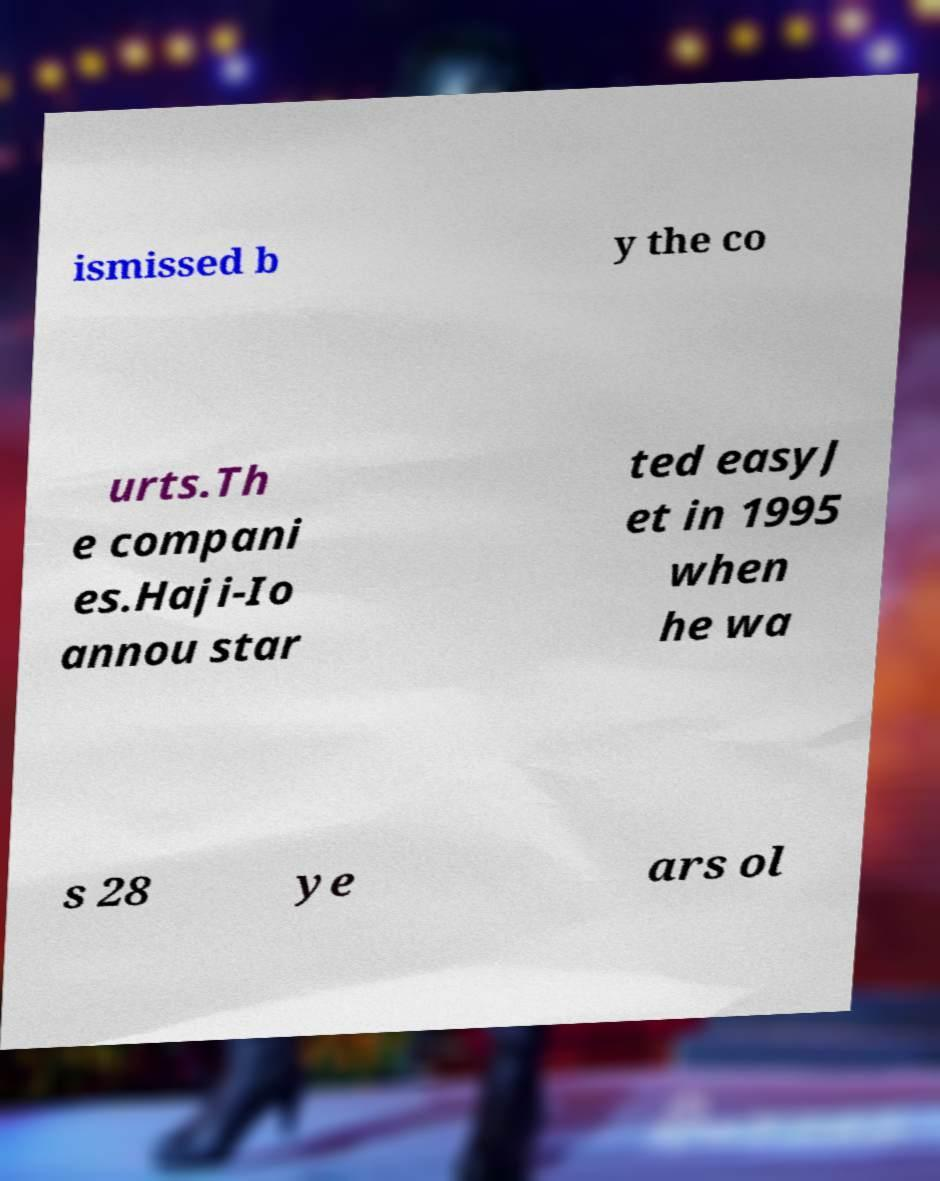What messages or text are displayed in this image? I need them in a readable, typed format. ismissed b y the co urts.Th e compani es.Haji-Io annou star ted easyJ et in 1995 when he wa s 28 ye ars ol 